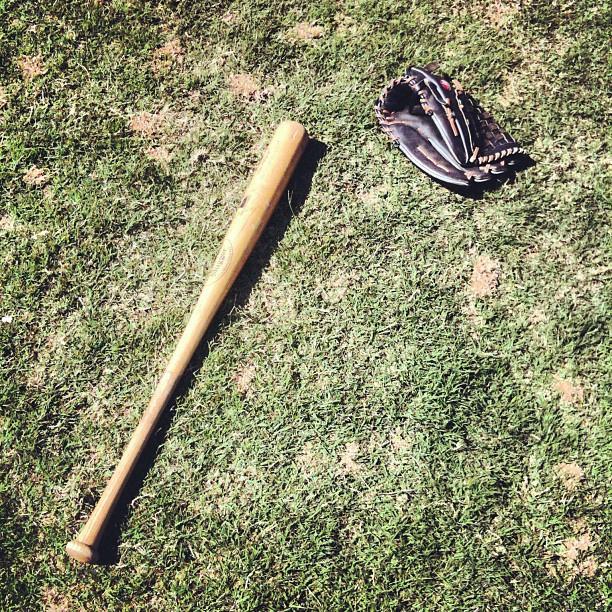What missing object is needed to play this game?
Concise answer only. Ball. What is the bat leaned against?
Concise answer only. Ground. Is anyone holding the bat?
Quick response, please. No. What is this equipment used for?
Keep it brief. Baseball. What colors are the bat?
Answer briefly. Brown. 